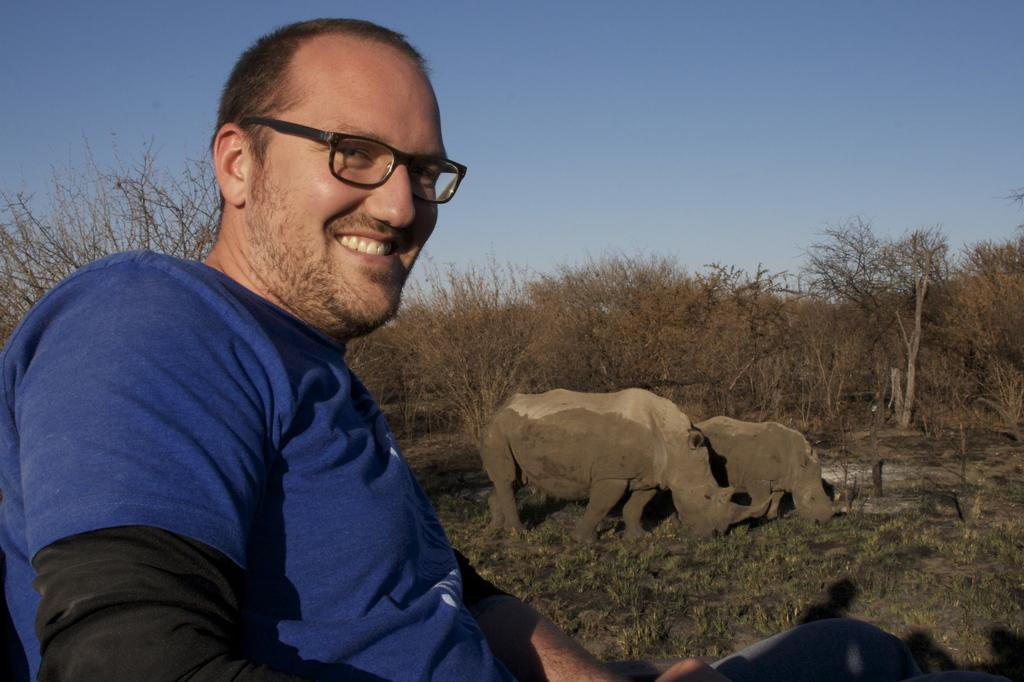What is the main subject of the image? The main subject of the image is a man. Can you describe the man's appearance? The man is wearing clothes and spectacles, and he is smiling. What can be seen in the background of the image? There is grass, mud, trees, and a pale blue sky in the image. Are there any animals present in the image? Yes, there are two rhinos in the image. What type of weather is depicted in the image? The provided facts do not mention any specific weather conditions, so we cannot determine the weather from the image. What is the government's stance on the man's actions in the image? The image does not provide any information about the man's actions or the government's stance, so we cannot answer this question. 